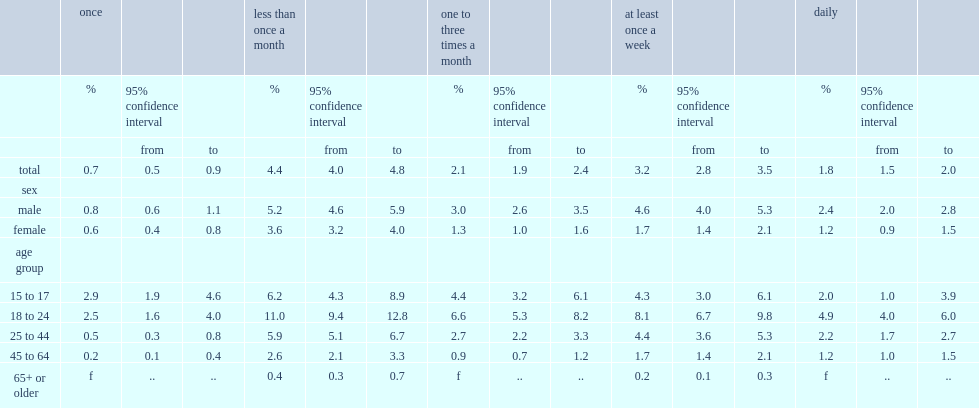What was the percentage of daily use in the previous year reported by the population aged 15 or older? 1.8. What was the percentage of at least weekly use in the previous year reported by the population aged 15 or older? 3.2. How many times was daily use as common among males as females? 2. Was daily use more coommon at ages 18 to 24 of among younger people based on percentage? 18 to 24. Was daily use more coommon at ages 18 to 24 of among older people based on percentage? 18 to 24. 